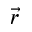<formula> <loc_0><loc_0><loc_500><loc_500>\vec { r }</formula> 